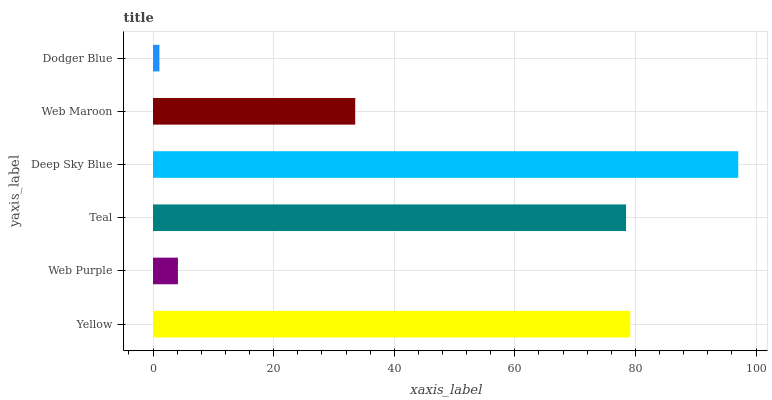Is Dodger Blue the minimum?
Answer yes or no. Yes. Is Deep Sky Blue the maximum?
Answer yes or no. Yes. Is Web Purple the minimum?
Answer yes or no. No. Is Web Purple the maximum?
Answer yes or no. No. Is Yellow greater than Web Purple?
Answer yes or no. Yes. Is Web Purple less than Yellow?
Answer yes or no. Yes. Is Web Purple greater than Yellow?
Answer yes or no. No. Is Yellow less than Web Purple?
Answer yes or no. No. Is Teal the high median?
Answer yes or no. Yes. Is Web Maroon the low median?
Answer yes or no. Yes. Is Web Purple the high median?
Answer yes or no. No. Is Teal the low median?
Answer yes or no. No. 